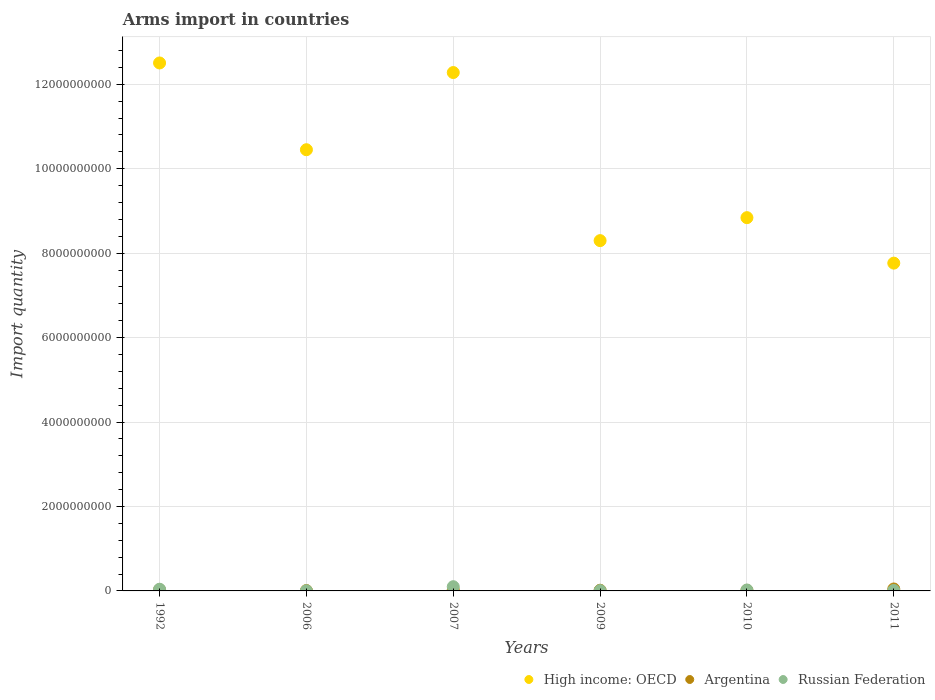How many different coloured dotlines are there?
Ensure brevity in your answer.  3. Is the number of dotlines equal to the number of legend labels?
Your answer should be compact. Yes. What is the total arms import in High income: OECD in 2009?
Offer a terse response. 8.30e+09. Across all years, what is the maximum total arms import in Argentina?
Offer a terse response. 4.60e+07. Across all years, what is the minimum total arms import in High income: OECD?
Ensure brevity in your answer.  7.76e+09. In which year was the total arms import in Russian Federation maximum?
Ensure brevity in your answer.  2007. In which year was the total arms import in Russian Federation minimum?
Provide a short and direct response. 2006. What is the total total arms import in Argentina in the graph?
Provide a short and direct response. 1.36e+08. What is the difference between the total arms import in Russian Federation in 2006 and that in 2007?
Ensure brevity in your answer.  -9.60e+07. What is the difference between the total arms import in Argentina in 2006 and the total arms import in Russian Federation in 2011?
Make the answer very short. -2.00e+06. What is the average total arms import in High income: OECD per year?
Provide a short and direct response. 1.00e+1. In the year 2011, what is the difference between the total arms import in Russian Federation and total arms import in Argentina?
Provide a short and direct response. -3.50e+07. What is the ratio of the total arms import in High income: OECD in 2007 to that in 2010?
Offer a very short reply. 1.39. Is the total arms import in Argentina in 2006 less than that in 2011?
Ensure brevity in your answer.  Yes. Is the difference between the total arms import in Russian Federation in 1992 and 2009 greater than the difference between the total arms import in Argentina in 1992 and 2009?
Provide a succinct answer. Yes. What is the difference between the highest and the second highest total arms import in Russian Federation?
Offer a very short reply. 6.00e+07. What is the difference between the highest and the lowest total arms import in Russian Federation?
Your answer should be very brief. 9.60e+07. In how many years, is the total arms import in Argentina greater than the average total arms import in Argentina taken over all years?
Ensure brevity in your answer.  3. Is the sum of the total arms import in Argentina in 1992 and 2009 greater than the maximum total arms import in Russian Federation across all years?
Your answer should be very brief. No. Is the total arms import in Russian Federation strictly greater than the total arms import in Argentina over the years?
Your answer should be very brief. No. Is the total arms import in Russian Federation strictly less than the total arms import in Argentina over the years?
Give a very brief answer. No. How many dotlines are there?
Offer a terse response. 3. How many years are there in the graph?
Make the answer very short. 6. Are the values on the major ticks of Y-axis written in scientific E-notation?
Ensure brevity in your answer.  No. How many legend labels are there?
Your answer should be very brief. 3. What is the title of the graph?
Give a very brief answer. Arms import in countries. What is the label or title of the X-axis?
Make the answer very short. Years. What is the label or title of the Y-axis?
Ensure brevity in your answer.  Import quantity. What is the Import quantity of High income: OECD in 1992?
Provide a succinct answer. 1.25e+1. What is the Import quantity in Argentina in 1992?
Your answer should be very brief. 2.70e+07. What is the Import quantity in Russian Federation in 1992?
Give a very brief answer. 4.00e+07. What is the Import quantity of High income: OECD in 2006?
Offer a very short reply. 1.04e+1. What is the Import quantity in Argentina in 2006?
Your response must be concise. 9.00e+06. What is the Import quantity of Russian Federation in 2006?
Keep it short and to the point. 4.00e+06. What is the Import quantity of High income: OECD in 2007?
Your answer should be very brief. 1.23e+1. What is the Import quantity of Argentina in 2007?
Your answer should be compact. 2.40e+07. What is the Import quantity in High income: OECD in 2009?
Your response must be concise. 8.30e+09. What is the Import quantity in Argentina in 2009?
Your answer should be compact. 1.60e+07. What is the Import quantity of Russian Federation in 2009?
Ensure brevity in your answer.  8.00e+06. What is the Import quantity of High income: OECD in 2010?
Keep it short and to the point. 8.84e+09. What is the Import quantity of Argentina in 2010?
Keep it short and to the point. 1.40e+07. What is the Import quantity in Russian Federation in 2010?
Your answer should be very brief. 2.20e+07. What is the Import quantity of High income: OECD in 2011?
Keep it short and to the point. 7.76e+09. What is the Import quantity of Argentina in 2011?
Make the answer very short. 4.60e+07. What is the Import quantity in Russian Federation in 2011?
Ensure brevity in your answer.  1.10e+07. Across all years, what is the maximum Import quantity in High income: OECD?
Your answer should be compact. 1.25e+1. Across all years, what is the maximum Import quantity of Argentina?
Your answer should be very brief. 4.60e+07. Across all years, what is the minimum Import quantity in High income: OECD?
Provide a short and direct response. 7.76e+09. Across all years, what is the minimum Import quantity of Argentina?
Offer a very short reply. 9.00e+06. Across all years, what is the minimum Import quantity in Russian Federation?
Offer a terse response. 4.00e+06. What is the total Import quantity of High income: OECD in the graph?
Offer a very short reply. 6.01e+1. What is the total Import quantity in Argentina in the graph?
Make the answer very short. 1.36e+08. What is the total Import quantity in Russian Federation in the graph?
Provide a succinct answer. 1.85e+08. What is the difference between the Import quantity in High income: OECD in 1992 and that in 2006?
Keep it short and to the point. 2.06e+09. What is the difference between the Import quantity of Argentina in 1992 and that in 2006?
Your answer should be very brief. 1.80e+07. What is the difference between the Import quantity of Russian Federation in 1992 and that in 2006?
Provide a short and direct response. 3.60e+07. What is the difference between the Import quantity of High income: OECD in 1992 and that in 2007?
Offer a very short reply. 2.27e+08. What is the difference between the Import quantity of Argentina in 1992 and that in 2007?
Provide a short and direct response. 3.00e+06. What is the difference between the Import quantity of Russian Federation in 1992 and that in 2007?
Ensure brevity in your answer.  -6.00e+07. What is the difference between the Import quantity in High income: OECD in 1992 and that in 2009?
Your response must be concise. 4.21e+09. What is the difference between the Import quantity in Argentina in 1992 and that in 2009?
Keep it short and to the point. 1.10e+07. What is the difference between the Import quantity of Russian Federation in 1992 and that in 2009?
Ensure brevity in your answer.  3.20e+07. What is the difference between the Import quantity of High income: OECD in 1992 and that in 2010?
Give a very brief answer. 3.66e+09. What is the difference between the Import quantity in Argentina in 1992 and that in 2010?
Ensure brevity in your answer.  1.30e+07. What is the difference between the Import quantity in Russian Federation in 1992 and that in 2010?
Your answer should be very brief. 1.80e+07. What is the difference between the Import quantity of High income: OECD in 1992 and that in 2011?
Your response must be concise. 4.74e+09. What is the difference between the Import quantity in Argentina in 1992 and that in 2011?
Make the answer very short. -1.90e+07. What is the difference between the Import quantity in Russian Federation in 1992 and that in 2011?
Your response must be concise. 2.90e+07. What is the difference between the Import quantity of High income: OECD in 2006 and that in 2007?
Ensure brevity in your answer.  -1.83e+09. What is the difference between the Import quantity of Argentina in 2006 and that in 2007?
Offer a very short reply. -1.50e+07. What is the difference between the Import quantity of Russian Federation in 2006 and that in 2007?
Your response must be concise. -9.60e+07. What is the difference between the Import quantity in High income: OECD in 2006 and that in 2009?
Keep it short and to the point. 2.15e+09. What is the difference between the Import quantity of Argentina in 2006 and that in 2009?
Make the answer very short. -7.00e+06. What is the difference between the Import quantity in High income: OECD in 2006 and that in 2010?
Your answer should be compact. 1.61e+09. What is the difference between the Import quantity in Argentina in 2006 and that in 2010?
Keep it short and to the point. -5.00e+06. What is the difference between the Import quantity in Russian Federation in 2006 and that in 2010?
Offer a terse response. -1.80e+07. What is the difference between the Import quantity of High income: OECD in 2006 and that in 2011?
Make the answer very short. 2.69e+09. What is the difference between the Import quantity of Argentina in 2006 and that in 2011?
Give a very brief answer. -3.70e+07. What is the difference between the Import quantity of Russian Federation in 2006 and that in 2011?
Give a very brief answer. -7.00e+06. What is the difference between the Import quantity in High income: OECD in 2007 and that in 2009?
Ensure brevity in your answer.  3.98e+09. What is the difference between the Import quantity of Russian Federation in 2007 and that in 2009?
Give a very brief answer. 9.20e+07. What is the difference between the Import quantity in High income: OECD in 2007 and that in 2010?
Keep it short and to the point. 3.44e+09. What is the difference between the Import quantity of Argentina in 2007 and that in 2010?
Give a very brief answer. 1.00e+07. What is the difference between the Import quantity in Russian Federation in 2007 and that in 2010?
Make the answer very short. 7.80e+07. What is the difference between the Import quantity of High income: OECD in 2007 and that in 2011?
Make the answer very short. 4.51e+09. What is the difference between the Import quantity in Argentina in 2007 and that in 2011?
Your response must be concise. -2.20e+07. What is the difference between the Import quantity in Russian Federation in 2007 and that in 2011?
Your answer should be compact. 8.90e+07. What is the difference between the Import quantity in High income: OECD in 2009 and that in 2010?
Make the answer very short. -5.44e+08. What is the difference between the Import quantity in Russian Federation in 2009 and that in 2010?
Keep it short and to the point. -1.40e+07. What is the difference between the Import quantity of High income: OECD in 2009 and that in 2011?
Offer a very short reply. 5.33e+08. What is the difference between the Import quantity of Argentina in 2009 and that in 2011?
Give a very brief answer. -3.00e+07. What is the difference between the Import quantity in Russian Federation in 2009 and that in 2011?
Keep it short and to the point. -3.00e+06. What is the difference between the Import quantity of High income: OECD in 2010 and that in 2011?
Ensure brevity in your answer.  1.08e+09. What is the difference between the Import quantity in Argentina in 2010 and that in 2011?
Offer a very short reply. -3.20e+07. What is the difference between the Import quantity in Russian Federation in 2010 and that in 2011?
Make the answer very short. 1.10e+07. What is the difference between the Import quantity of High income: OECD in 1992 and the Import quantity of Argentina in 2006?
Your answer should be compact. 1.25e+1. What is the difference between the Import quantity in High income: OECD in 1992 and the Import quantity in Russian Federation in 2006?
Your answer should be very brief. 1.25e+1. What is the difference between the Import quantity in Argentina in 1992 and the Import quantity in Russian Federation in 2006?
Give a very brief answer. 2.30e+07. What is the difference between the Import quantity of High income: OECD in 1992 and the Import quantity of Argentina in 2007?
Ensure brevity in your answer.  1.25e+1. What is the difference between the Import quantity of High income: OECD in 1992 and the Import quantity of Russian Federation in 2007?
Make the answer very short. 1.24e+1. What is the difference between the Import quantity in Argentina in 1992 and the Import quantity in Russian Federation in 2007?
Offer a very short reply. -7.30e+07. What is the difference between the Import quantity of High income: OECD in 1992 and the Import quantity of Argentina in 2009?
Your response must be concise. 1.25e+1. What is the difference between the Import quantity of High income: OECD in 1992 and the Import quantity of Russian Federation in 2009?
Provide a short and direct response. 1.25e+1. What is the difference between the Import quantity in Argentina in 1992 and the Import quantity in Russian Federation in 2009?
Offer a terse response. 1.90e+07. What is the difference between the Import quantity in High income: OECD in 1992 and the Import quantity in Argentina in 2010?
Ensure brevity in your answer.  1.25e+1. What is the difference between the Import quantity of High income: OECD in 1992 and the Import quantity of Russian Federation in 2010?
Keep it short and to the point. 1.25e+1. What is the difference between the Import quantity in High income: OECD in 1992 and the Import quantity in Argentina in 2011?
Give a very brief answer. 1.25e+1. What is the difference between the Import quantity of High income: OECD in 1992 and the Import quantity of Russian Federation in 2011?
Give a very brief answer. 1.25e+1. What is the difference between the Import quantity in Argentina in 1992 and the Import quantity in Russian Federation in 2011?
Offer a terse response. 1.60e+07. What is the difference between the Import quantity of High income: OECD in 2006 and the Import quantity of Argentina in 2007?
Give a very brief answer. 1.04e+1. What is the difference between the Import quantity in High income: OECD in 2006 and the Import quantity in Russian Federation in 2007?
Offer a very short reply. 1.04e+1. What is the difference between the Import quantity of Argentina in 2006 and the Import quantity of Russian Federation in 2007?
Your answer should be very brief. -9.10e+07. What is the difference between the Import quantity in High income: OECD in 2006 and the Import quantity in Argentina in 2009?
Ensure brevity in your answer.  1.04e+1. What is the difference between the Import quantity of High income: OECD in 2006 and the Import quantity of Russian Federation in 2009?
Your answer should be compact. 1.04e+1. What is the difference between the Import quantity in High income: OECD in 2006 and the Import quantity in Argentina in 2010?
Your answer should be very brief. 1.04e+1. What is the difference between the Import quantity in High income: OECD in 2006 and the Import quantity in Russian Federation in 2010?
Offer a terse response. 1.04e+1. What is the difference between the Import quantity in Argentina in 2006 and the Import quantity in Russian Federation in 2010?
Provide a succinct answer. -1.30e+07. What is the difference between the Import quantity in High income: OECD in 2006 and the Import quantity in Argentina in 2011?
Make the answer very short. 1.04e+1. What is the difference between the Import quantity of High income: OECD in 2006 and the Import quantity of Russian Federation in 2011?
Ensure brevity in your answer.  1.04e+1. What is the difference between the Import quantity in Argentina in 2006 and the Import quantity in Russian Federation in 2011?
Ensure brevity in your answer.  -2.00e+06. What is the difference between the Import quantity of High income: OECD in 2007 and the Import quantity of Argentina in 2009?
Your response must be concise. 1.23e+1. What is the difference between the Import quantity of High income: OECD in 2007 and the Import quantity of Russian Federation in 2009?
Your answer should be very brief. 1.23e+1. What is the difference between the Import quantity of Argentina in 2007 and the Import quantity of Russian Federation in 2009?
Your answer should be very brief. 1.60e+07. What is the difference between the Import quantity in High income: OECD in 2007 and the Import quantity in Argentina in 2010?
Keep it short and to the point. 1.23e+1. What is the difference between the Import quantity in High income: OECD in 2007 and the Import quantity in Russian Federation in 2010?
Ensure brevity in your answer.  1.23e+1. What is the difference between the Import quantity of High income: OECD in 2007 and the Import quantity of Argentina in 2011?
Make the answer very short. 1.22e+1. What is the difference between the Import quantity in High income: OECD in 2007 and the Import quantity in Russian Federation in 2011?
Your response must be concise. 1.23e+1. What is the difference between the Import quantity in Argentina in 2007 and the Import quantity in Russian Federation in 2011?
Ensure brevity in your answer.  1.30e+07. What is the difference between the Import quantity in High income: OECD in 2009 and the Import quantity in Argentina in 2010?
Make the answer very short. 8.28e+09. What is the difference between the Import quantity of High income: OECD in 2009 and the Import quantity of Russian Federation in 2010?
Keep it short and to the point. 8.28e+09. What is the difference between the Import quantity of Argentina in 2009 and the Import quantity of Russian Federation in 2010?
Provide a succinct answer. -6.00e+06. What is the difference between the Import quantity in High income: OECD in 2009 and the Import quantity in Argentina in 2011?
Keep it short and to the point. 8.25e+09. What is the difference between the Import quantity of High income: OECD in 2009 and the Import quantity of Russian Federation in 2011?
Provide a succinct answer. 8.29e+09. What is the difference between the Import quantity in High income: OECD in 2010 and the Import quantity in Argentina in 2011?
Your answer should be compact. 8.80e+09. What is the difference between the Import quantity in High income: OECD in 2010 and the Import quantity in Russian Federation in 2011?
Keep it short and to the point. 8.83e+09. What is the difference between the Import quantity of Argentina in 2010 and the Import quantity of Russian Federation in 2011?
Give a very brief answer. 3.00e+06. What is the average Import quantity in High income: OECD per year?
Ensure brevity in your answer.  1.00e+1. What is the average Import quantity of Argentina per year?
Provide a short and direct response. 2.27e+07. What is the average Import quantity of Russian Federation per year?
Keep it short and to the point. 3.08e+07. In the year 1992, what is the difference between the Import quantity in High income: OECD and Import quantity in Argentina?
Your response must be concise. 1.25e+1. In the year 1992, what is the difference between the Import quantity in High income: OECD and Import quantity in Russian Federation?
Keep it short and to the point. 1.25e+1. In the year 1992, what is the difference between the Import quantity in Argentina and Import quantity in Russian Federation?
Your response must be concise. -1.30e+07. In the year 2006, what is the difference between the Import quantity of High income: OECD and Import quantity of Argentina?
Provide a succinct answer. 1.04e+1. In the year 2006, what is the difference between the Import quantity of High income: OECD and Import quantity of Russian Federation?
Your response must be concise. 1.04e+1. In the year 2006, what is the difference between the Import quantity in Argentina and Import quantity in Russian Federation?
Make the answer very short. 5.00e+06. In the year 2007, what is the difference between the Import quantity of High income: OECD and Import quantity of Argentina?
Provide a succinct answer. 1.23e+1. In the year 2007, what is the difference between the Import quantity in High income: OECD and Import quantity in Russian Federation?
Give a very brief answer. 1.22e+1. In the year 2007, what is the difference between the Import quantity in Argentina and Import quantity in Russian Federation?
Your answer should be compact. -7.60e+07. In the year 2009, what is the difference between the Import quantity of High income: OECD and Import quantity of Argentina?
Make the answer very short. 8.28e+09. In the year 2009, what is the difference between the Import quantity in High income: OECD and Import quantity in Russian Federation?
Offer a very short reply. 8.29e+09. In the year 2010, what is the difference between the Import quantity of High income: OECD and Import quantity of Argentina?
Provide a succinct answer. 8.83e+09. In the year 2010, what is the difference between the Import quantity of High income: OECD and Import quantity of Russian Federation?
Your answer should be very brief. 8.82e+09. In the year 2010, what is the difference between the Import quantity of Argentina and Import quantity of Russian Federation?
Offer a terse response. -8.00e+06. In the year 2011, what is the difference between the Import quantity of High income: OECD and Import quantity of Argentina?
Your answer should be compact. 7.72e+09. In the year 2011, what is the difference between the Import quantity of High income: OECD and Import quantity of Russian Federation?
Provide a succinct answer. 7.75e+09. In the year 2011, what is the difference between the Import quantity of Argentina and Import quantity of Russian Federation?
Offer a very short reply. 3.50e+07. What is the ratio of the Import quantity of High income: OECD in 1992 to that in 2006?
Make the answer very short. 1.2. What is the ratio of the Import quantity of Argentina in 1992 to that in 2006?
Your response must be concise. 3. What is the ratio of the Import quantity of High income: OECD in 1992 to that in 2007?
Make the answer very short. 1.02. What is the ratio of the Import quantity of Argentina in 1992 to that in 2007?
Give a very brief answer. 1.12. What is the ratio of the Import quantity of High income: OECD in 1992 to that in 2009?
Your answer should be compact. 1.51. What is the ratio of the Import quantity of Argentina in 1992 to that in 2009?
Ensure brevity in your answer.  1.69. What is the ratio of the Import quantity in High income: OECD in 1992 to that in 2010?
Your response must be concise. 1.41. What is the ratio of the Import quantity of Argentina in 1992 to that in 2010?
Provide a succinct answer. 1.93. What is the ratio of the Import quantity in Russian Federation in 1992 to that in 2010?
Make the answer very short. 1.82. What is the ratio of the Import quantity of High income: OECD in 1992 to that in 2011?
Your answer should be compact. 1.61. What is the ratio of the Import quantity in Argentina in 1992 to that in 2011?
Provide a succinct answer. 0.59. What is the ratio of the Import quantity in Russian Federation in 1992 to that in 2011?
Your response must be concise. 3.64. What is the ratio of the Import quantity of High income: OECD in 2006 to that in 2007?
Your response must be concise. 0.85. What is the ratio of the Import quantity of Russian Federation in 2006 to that in 2007?
Provide a succinct answer. 0.04. What is the ratio of the Import quantity in High income: OECD in 2006 to that in 2009?
Offer a terse response. 1.26. What is the ratio of the Import quantity in Argentina in 2006 to that in 2009?
Offer a terse response. 0.56. What is the ratio of the Import quantity in Russian Federation in 2006 to that in 2009?
Offer a terse response. 0.5. What is the ratio of the Import quantity in High income: OECD in 2006 to that in 2010?
Offer a very short reply. 1.18. What is the ratio of the Import quantity of Argentina in 2006 to that in 2010?
Give a very brief answer. 0.64. What is the ratio of the Import quantity of Russian Federation in 2006 to that in 2010?
Your response must be concise. 0.18. What is the ratio of the Import quantity in High income: OECD in 2006 to that in 2011?
Offer a very short reply. 1.35. What is the ratio of the Import quantity in Argentina in 2006 to that in 2011?
Give a very brief answer. 0.2. What is the ratio of the Import quantity in Russian Federation in 2006 to that in 2011?
Your answer should be very brief. 0.36. What is the ratio of the Import quantity in High income: OECD in 2007 to that in 2009?
Keep it short and to the point. 1.48. What is the ratio of the Import quantity of Russian Federation in 2007 to that in 2009?
Your response must be concise. 12.5. What is the ratio of the Import quantity of High income: OECD in 2007 to that in 2010?
Your answer should be very brief. 1.39. What is the ratio of the Import quantity in Argentina in 2007 to that in 2010?
Provide a short and direct response. 1.71. What is the ratio of the Import quantity in Russian Federation in 2007 to that in 2010?
Your answer should be very brief. 4.55. What is the ratio of the Import quantity in High income: OECD in 2007 to that in 2011?
Provide a succinct answer. 1.58. What is the ratio of the Import quantity in Argentina in 2007 to that in 2011?
Provide a short and direct response. 0.52. What is the ratio of the Import quantity of Russian Federation in 2007 to that in 2011?
Ensure brevity in your answer.  9.09. What is the ratio of the Import quantity of High income: OECD in 2009 to that in 2010?
Provide a succinct answer. 0.94. What is the ratio of the Import quantity in Russian Federation in 2009 to that in 2010?
Your answer should be very brief. 0.36. What is the ratio of the Import quantity of High income: OECD in 2009 to that in 2011?
Provide a succinct answer. 1.07. What is the ratio of the Import quantity of Argentina in 2009 to that in 2011?
Give a very brief answer. 0.35. What is the ratio of the Import quantity of Russian Federation in 2009 to that in 2011?
Provide a short and direct response. 0.73. What is the ratio of the Import quantity of High income: OECD in 2010 to that in 2011?
Provide a short and direct response. 1.14. What is the ratio of the Import quantity in Argentina in 2010 to that in 2011?
Ensure brevity in your answer.  0.3. What is the difference between the highest and the second highest Import quantity in High income: OECD?
Keep it short and to the point. 2.27e+08. What is the difference between the highest and the second highest Import quantity of Argentina?
Keep it short and to the point. 1.90e+07. What is the difference between the highest and the second highest Import quantity in Russian Federation?
Offer a terse response. 6.00e+07. What is the difference between the highest and the lowest Import quantity of High income: OECD?
Your answer should be very brief. 4.74e+09. What is the difference between the highest and the lowest Import quantity in Argentina?
Make the answer very short. 3.70e+07. What is the difference between the highest and the lowest Import quantity in Russian Federation?
Your response must be concise. 9.60e+07. 